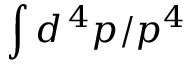Convert formula to latex. <formula><loc_0><loc_0><loc_500><loc_500>\int d ^ { \, 4 } p / p ^ { 4 }</formula> 